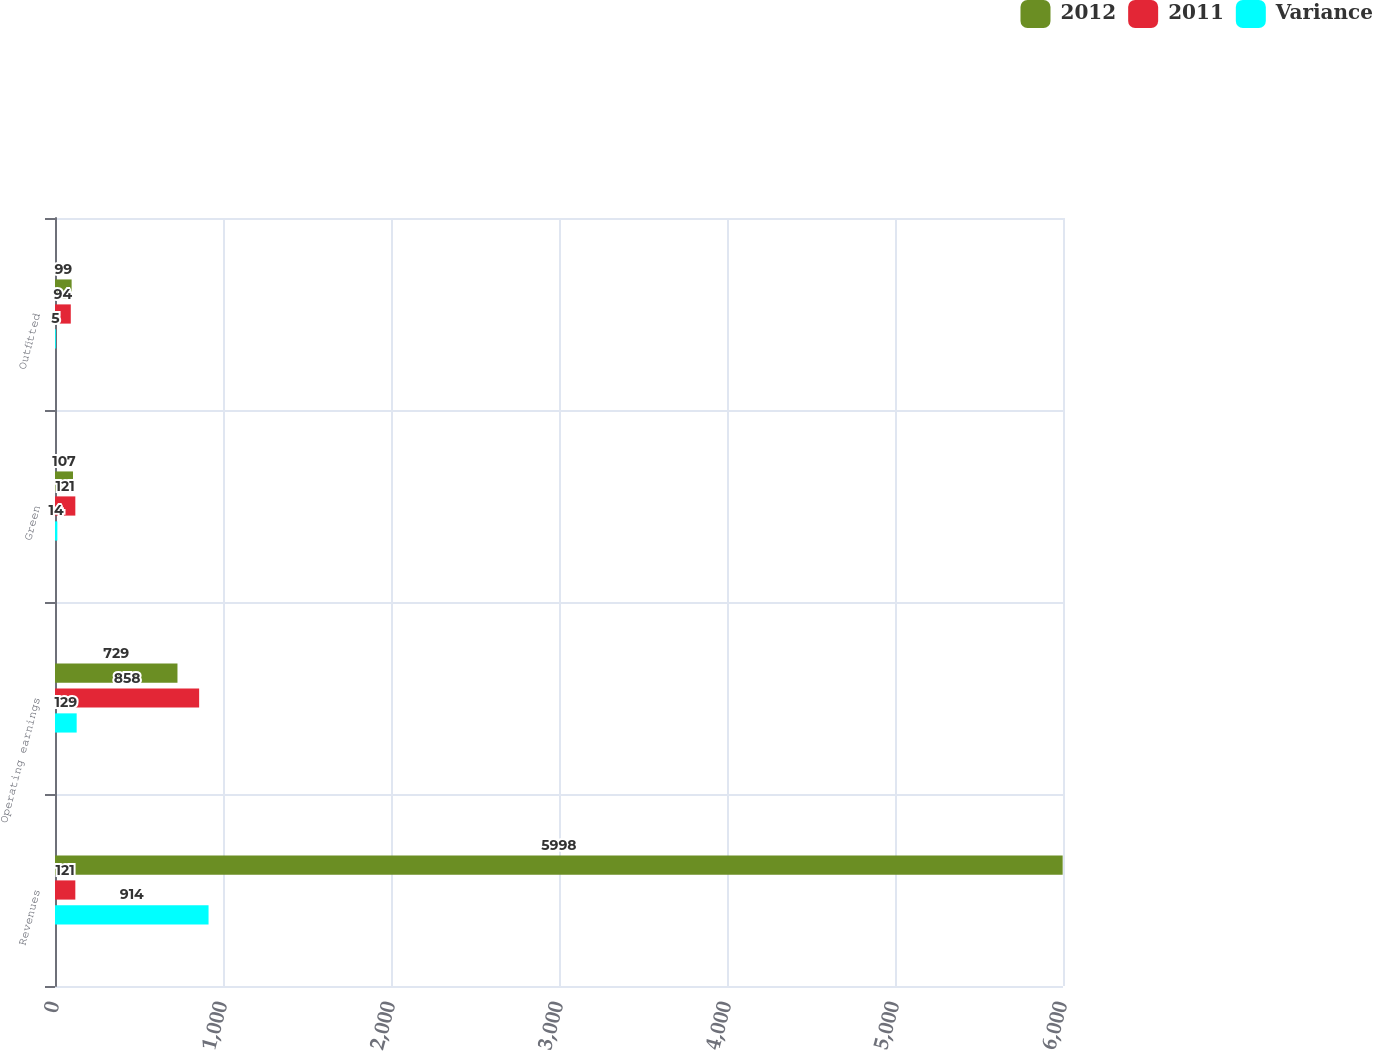Convert chart. <chart><loc_0><loc_0><loc_500><loc_500><stacked_bar_chart><ecel><fcel>Revenues<fcel>Operating earnings<fcel>Green<fcel>Outfitted<nl><fcel>2012<fcel>5998<fcel>729<fcel>107<fcel>99<nl><fcel>2011<fcel>121<fcel>858<fcel>121<fcel>94<nl><fcel>Variance<fcel>914<fcel>129<fcel>14<fcel>5<nl></chart> 